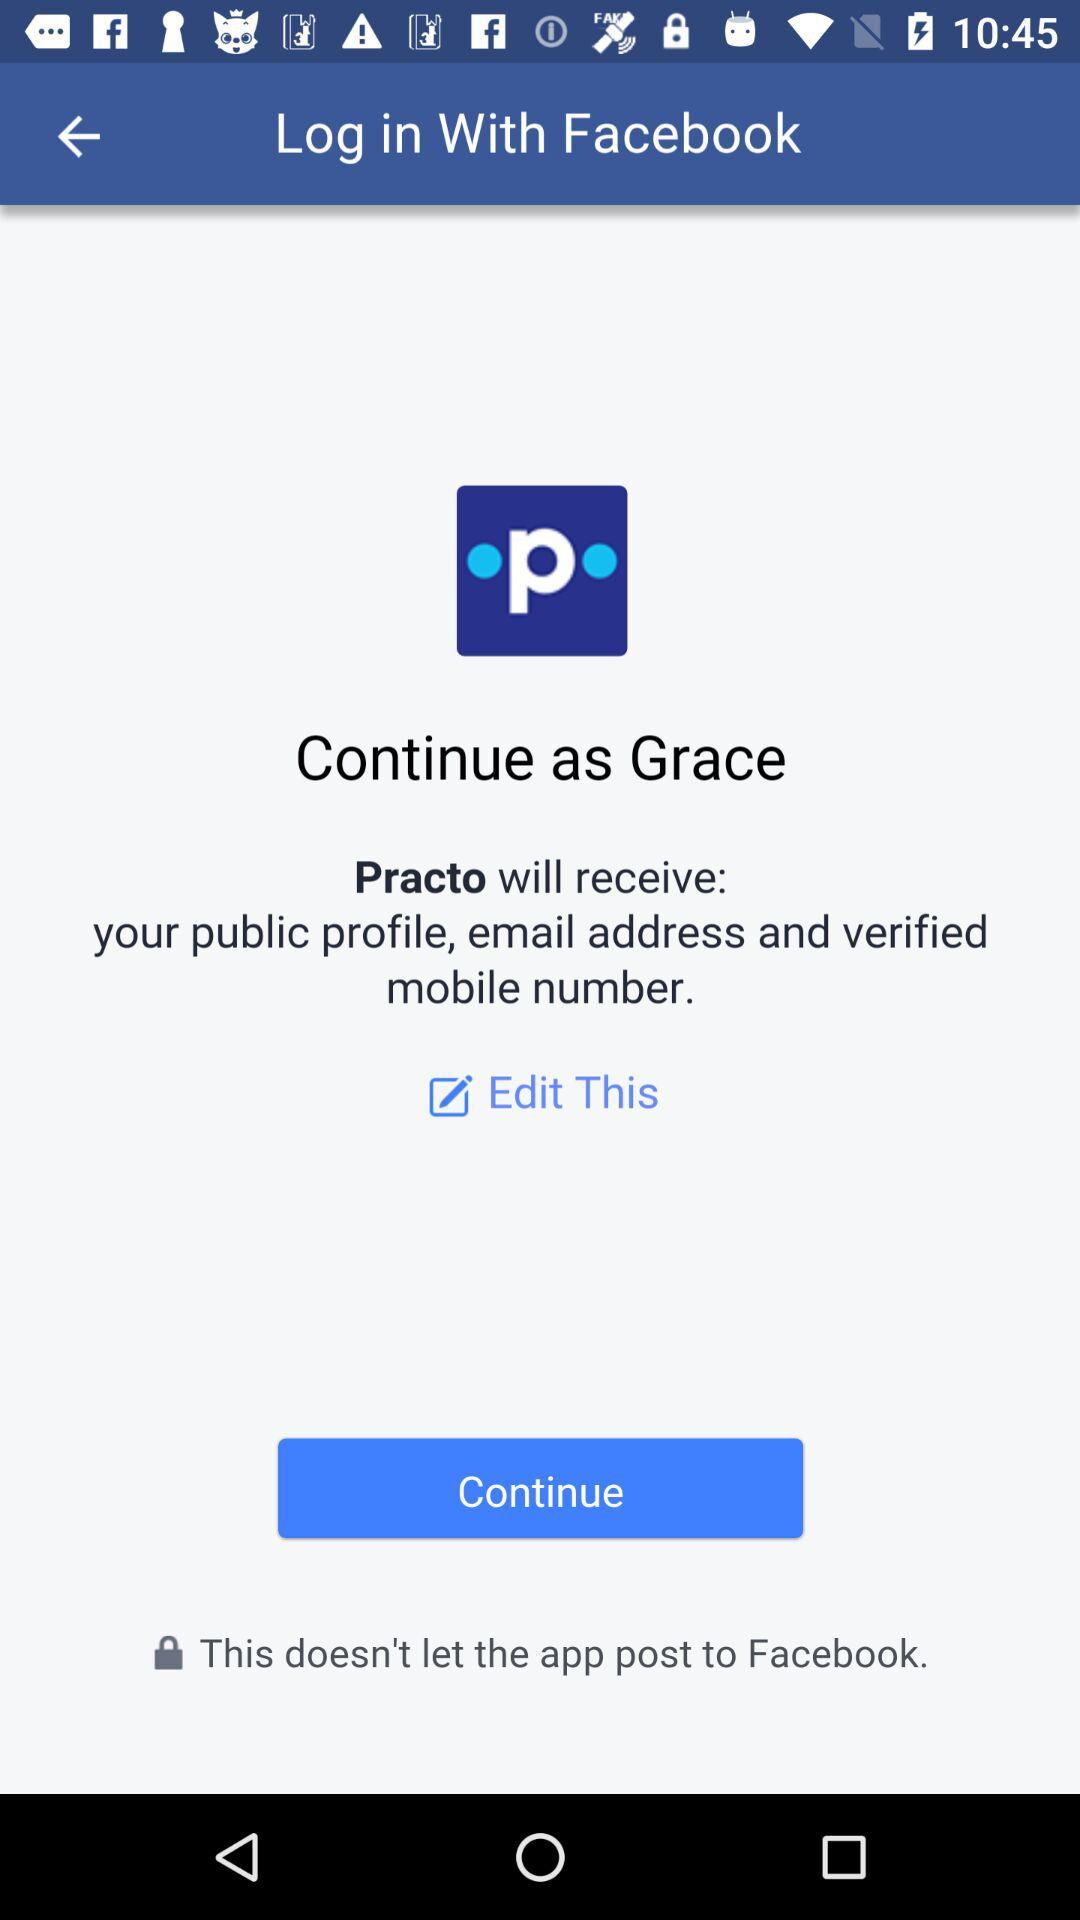What is the user name? The user name is Grace. 